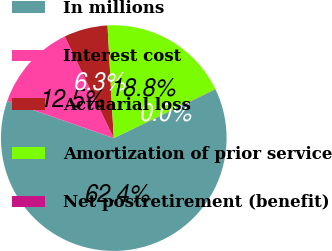Convert chart to OTSL. <chart><loc_0><loc_0><loc_500><loc_500><pie_chart><fcel>In millions<fcel>Interest cost<fcel>Actuarial loss<fcel>Amortization of prior service<fcel>Net postretirement (benefit)<nl><fcel>62.43%<fcel>12.51%<fcel>6.27%<fcel>18.75%<fcel>0.03%<nl></chart> 